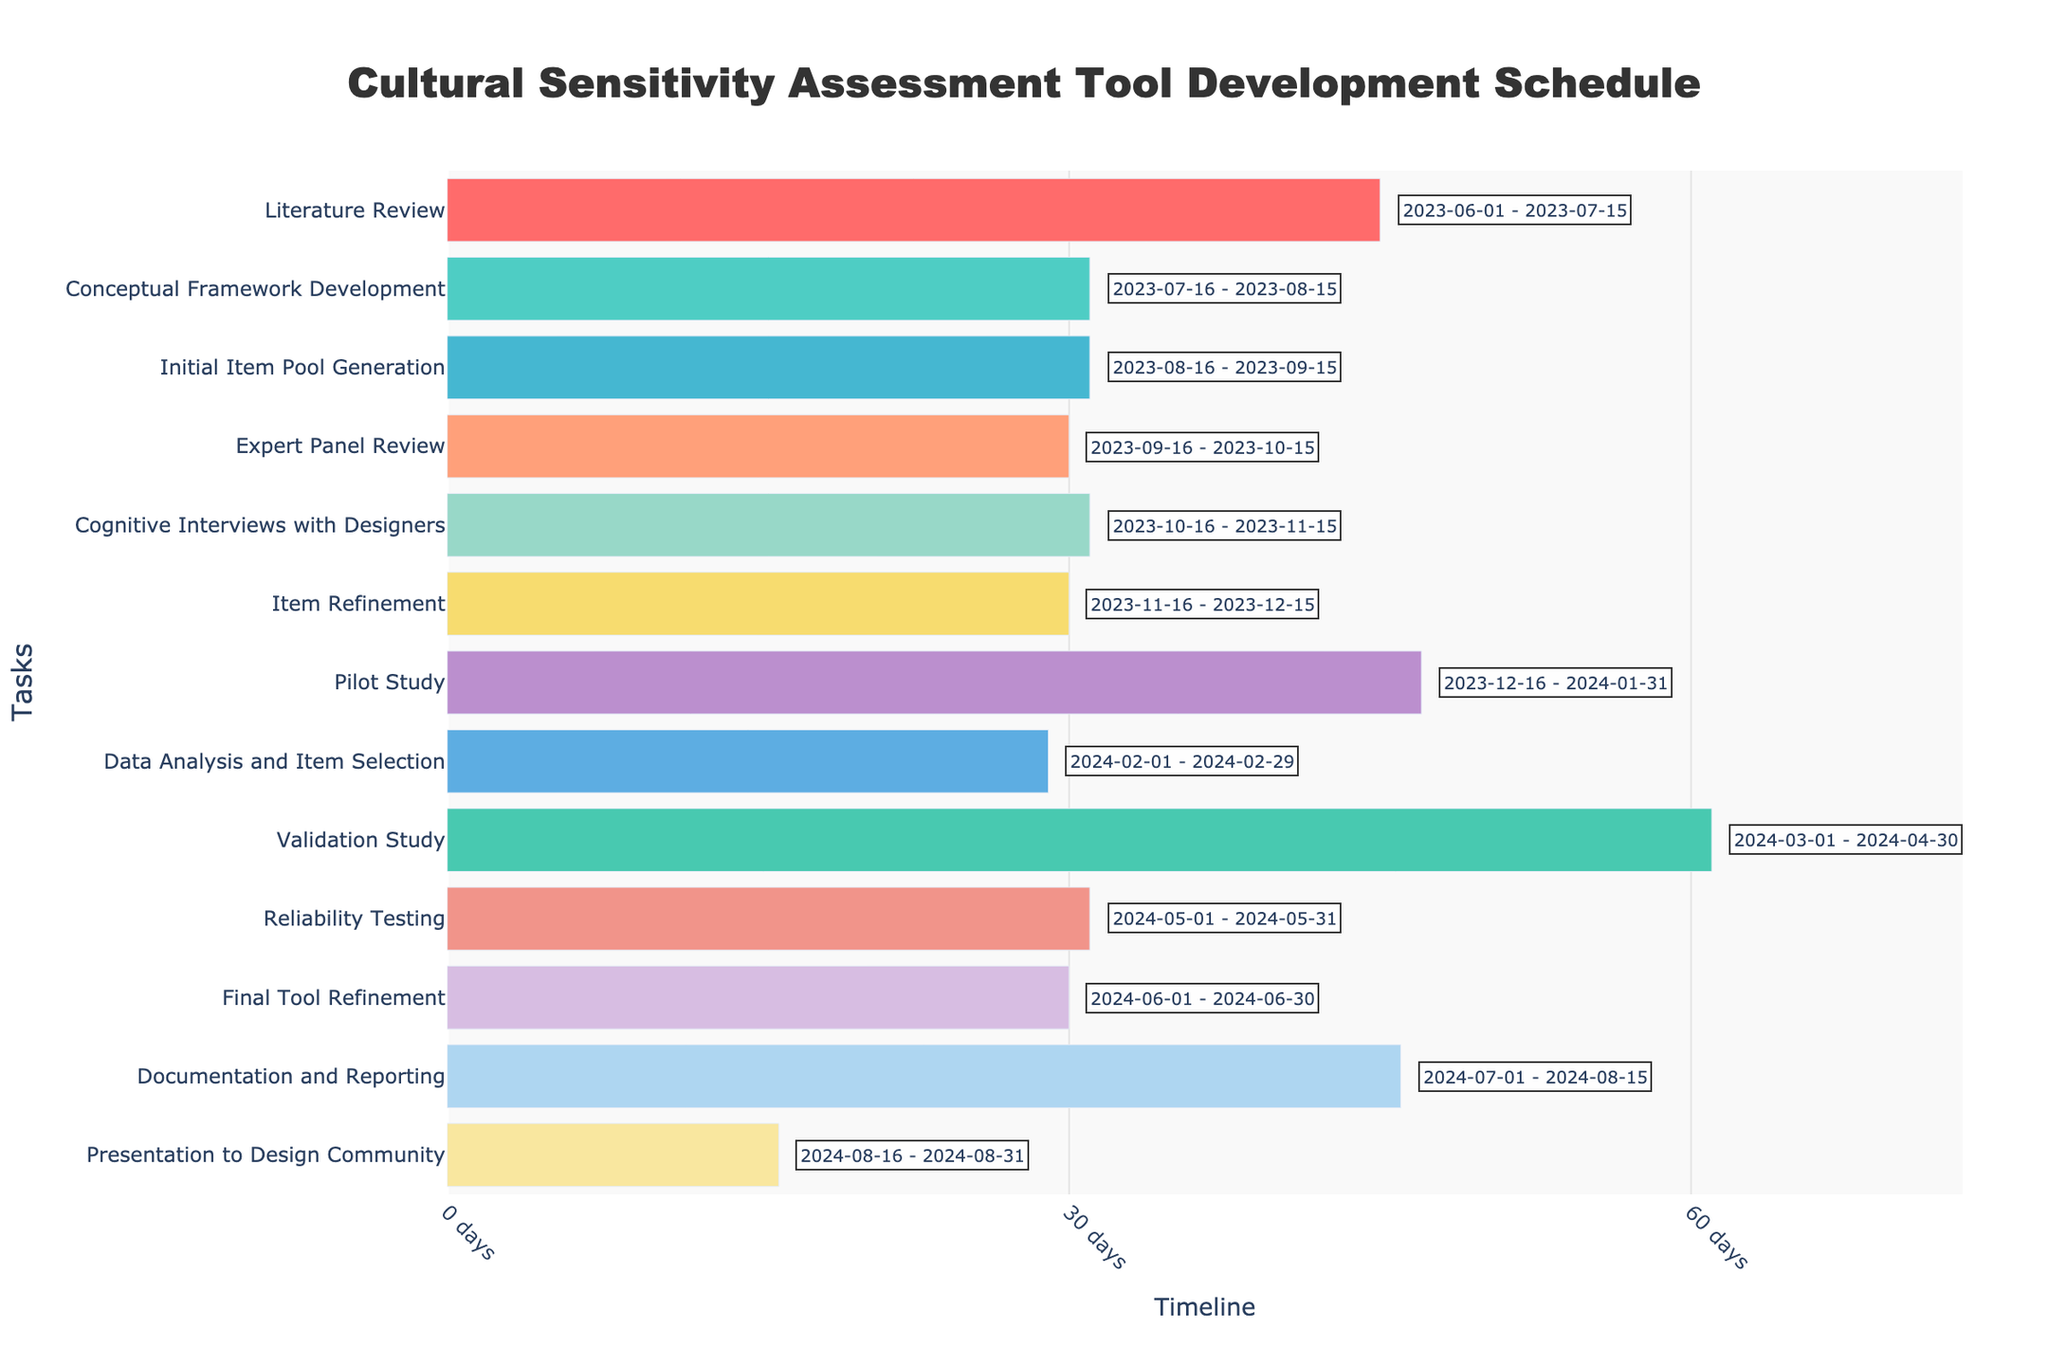What is the title of the Gantt chart? The title is usually located at the top center of the chart. It helps in identifying the primary purpose or subject of the chart.
Answer: Cultural Sensitivity Assessment Tool Development Schedule Which task has the longest duration? Look at the bars representing each task and compare their lengths. The task with the longest bar represents the longest duration in days.
Answer: Validation Study How many tasks are scheduled to start in 2023? Identify the bars that start within the range of 2023. Count these bars to get the number of tasks.
Answer: Eleven Which task ends in April 2024? Check the end dates for all tasks and find the one that ends in April 2024.
Answer: Validation Study How many days will be spent on the Literature Review? Look for the duration mentioned alongside the Literature Review task.
Answer: 45 days Which two consecutive tasks have the shortest combined duration? Calculate the durations of consecutive tasks and find the pair with the smallest sum.
Answer: Expert Panel Review and Cognitive Interviews with Designers (30 days + 31 days = 61 days) Are there any tasks that have the same duration? If so, which ones? Compare the duration values for each task and look for equal values.
Answer: Conceptual Framework Development, Initial Item Pool Generation, Cognitive Interviews with Designers, Reliability Testing (all 31 days) Which task starts immediately after the Pilot Study? Identify the end date of the Pilot Study and find the task that starts immediately after this date.
Answer: Data Analysis and Item Selection What is the combined duration of the Final Tool Refinement and Documentation and Reporting? Add the durations of the two specified tasks.
Answer: 30 days + 46 days = 76 days Over how many months does the entire project span? Identify the start date of the first task and the end date of the last task, then calculate the number of months between these dates.
Answer: June 2023 to August 2024, which is 15 months What color represents the Pilot Study task? Identify the color used for the bar representing the Pilot Study and describe it.
Answer: '#FFA07A' (or a shade of light orange/pink in natural language) 